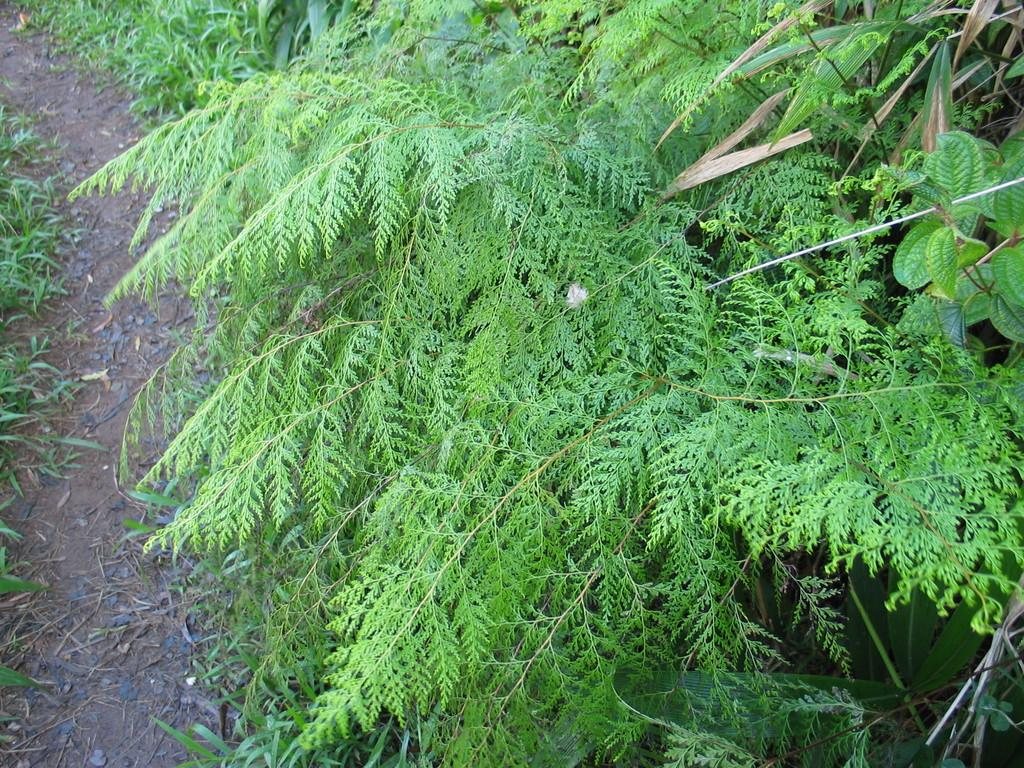What is the primary subject in the image? The primary subject in the image is many plants. Can you describe any specific features or structures in the image? Yes, there is a small walkway on the left side of the image. Where is the mom in the image? There is no mom present in the image. What type of detail can be seen on the plants in the image? The provided facts do not mention any specific details on the plants in the image. 